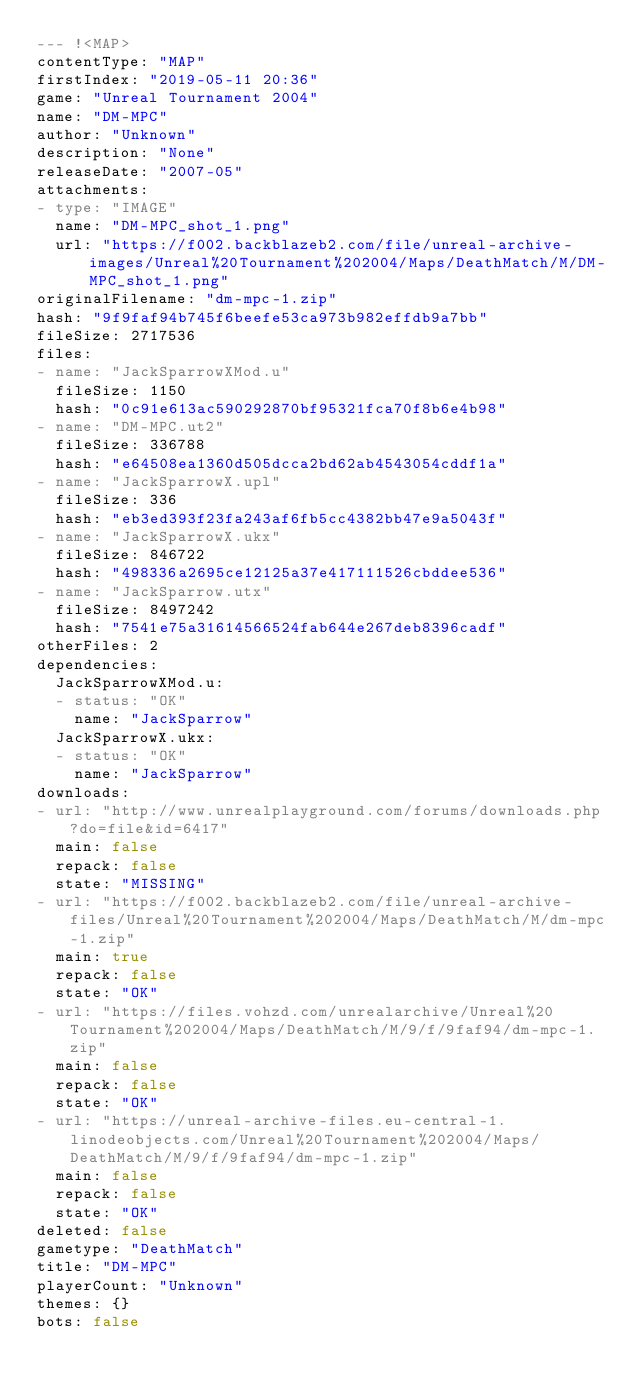<code> <loc_0><loc_0><loc_500><loc_500><_YAML_>--- !<MAP>
contentType: "MAP"
firstIndex: "2019-05-11 20:36"
game: "Unreal Tournament 2004"
name: "DM-MPC"
author: "Unknown"
description: "None"
releaseDate: "2007-05"
attachments:
- type: "IMAGE"
  name: "DM-MPC_shot_1.png"
  url: "https://f002.backblazeb2.com/file/unreal-archive-images/Unreal%20Tournament%202004/Maps/DeathMatch/M/DM-MPC_shot_1.png"
originalFilename: "dm-mpc-1.zip"
hash: "9f9faf94b745f6beefe53ca973b982effdb9a7bb"
fileSize: 2717536
files:
- name: "JackSparrowXMod.u"
  fileSize: 1150
  hash: "0c91e613ac590292870bf95321fca70f8b6e4b98"
- name: "DM-MPC.ut2"
  fileSize: 336788
  hash: "e64508ea1360d505dcca2bd62ab4543054cddf1a"
- name: "JackSparrowX.upl"
  fileSize: 336
  hash: "eb3ed393f23fa243af6fb5cc4382bb47e9a5043f"
- name: "JackSparrowX.ukx"
  fileSize: 846722
  hash: "498336a2695ce12125a37e417111526cbddee536"
- name: "JackSparrow.utx"
  fileSize: 8497242
  hash: "7541e75a31614566524fab644e267deb8396cadf"
otherFiles: 2
dependencies:
  JackSparrowXMod.u:
  - status: "OK"
    name: "JackSparrow"
  JackSparrowX.ukx:
  - status: "OK"
    name: "JackSparrow"
downloads:
- url: "http://www.unrealplayground.com/forums/downloads.php?do=file&id=6417"
  main: false
  repack: false
  state: "MISSING"
- url: "https://f002.backblazeb2.com/file/unreal-archive-files/Unreal%20Tournament%202004/Maps/DeathMatch/M/dm-mpc-1.zip"
  main: true
  repack: false
  state: "OK"
- url: "https://files.vohzd.com/unrealarchive/Unreal%20Tournament%202004/Maps/DeathMatch/M/9/f/9faf94/dm-mpc-1.zip"
  main: false
  repack: false
  state: "OK"
- url: "https://unreal-archive-files.eu-central-1.linodeobjects.com/Unreal%20Tournament%202004/Maps/DeathMatch/M/9/f/9faf94/dm-mpc-1.zip"
  main: false
  repack: false
  state: "OK"
deleted: false
gametype: "DeathMatch"
title: "DM-MPC"
playerCount: "Unknown"
themes: {}
bots: false
</code> 